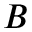Convert formula to latex. <formula><loc_0><loc_0><loc_500><loc_500>B</formula> 